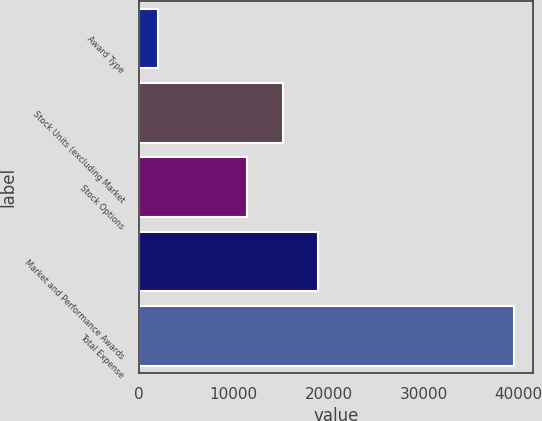Convert chart to OTSL. <chart><loc_0><loc_0><loc_500><loc_500><bar_chart><fcel>Award Type<fcel>Stock Units (excluding Market<fcel>Stock Options<fcel>Market and Performance Awards<fcel>Total Expense<nl><fcel>2013<fcel>15135.5<fcel>11385<fcel>18886<fcel>39518<nl></chart> 